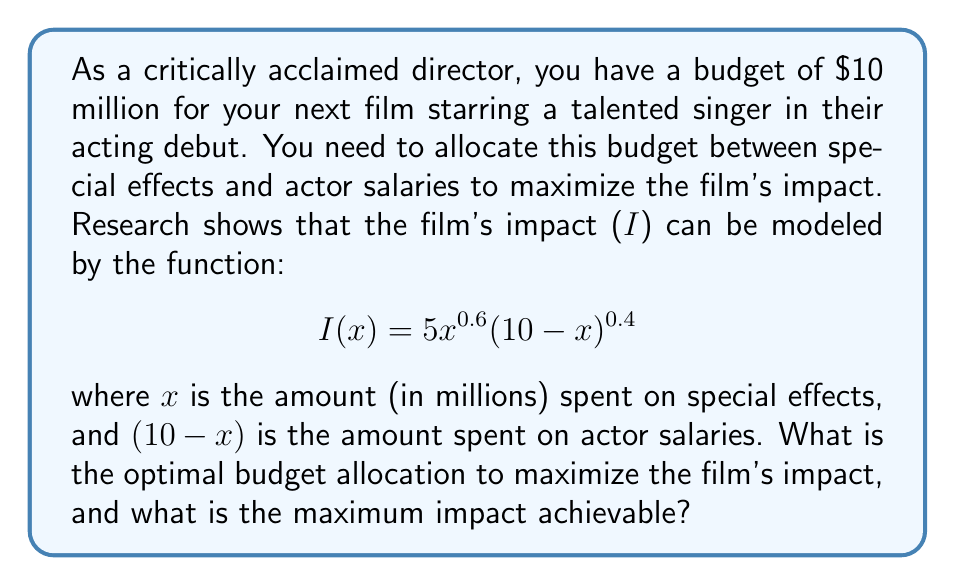Teach me how to tackle this problem. To solve this optimization problem, we need to find the maximum value of the impact function $I(x)$. We can do this by finding the critical points of the function and evaluating them.

1) First, let's find the derivative of $I(x)$:

   $$I'(x) = 5(0.6x^{-0.4}(10-x)^{0.4} - 0.4x^{0.6}(10-x)^{-0.6})$$

2) Set the derivative equal to zero to find the critical points:

   $$5(0.6x^{-0.4}(10-x)^{0.4} - 0.4x^{0.6}(10-x)^{-0.6}) = 0$$

3) Simplify:

   $$0.6x^{-0.4}(10-x)^{0.4} = 0.4x^{0.6}(10-x)^{-0.6}$$

4) Further simplification leads to:

   $$0.6(10-x) = 0.4x$$

5) Solve for x:

   $$6 - 0.6x = 0.4x$$
   $$6 = x$$

6) Therefore, the critical point is at $x = 6$.

7) To confirm this is a maximum, we can check the second derivative or evaluate the function at points on either side of $x = 6$.

8) The optimal allocation is $6 million for special effects and $4 million for actor salaries.

9) The maximum impact can be calculated by plugging $x = 6$ into the original function:

   $$I(6) = 5(6^{0.6})(4^{0.4}) \approx 11.62$$
Answer: The optimal budget allocation is $6 million for special effects and $4 million for actor salaries. The maximum achievable impact is approximately 11.62. 